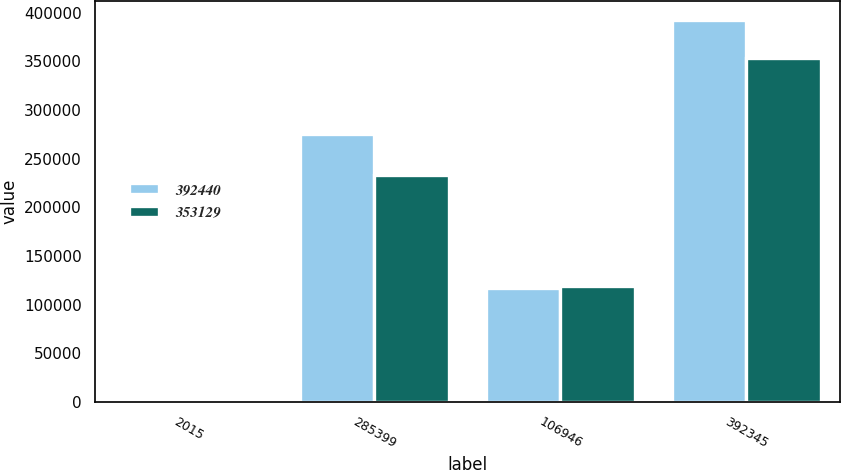Convert chart. <chart><loc_0><loc_0><loc_500><loc_500><stacked_bar_chart><ecel><fcel>2015<fcel>285399<fcel>106946<fcel>392345<nl><fcel>392440<fcel>2014<fcel>275334<fcel>117106<fcel>392440<nl><fcel>353129<fcel>2013<fcel>233530<fcel>119599<fcel>353129<nl></chart> 